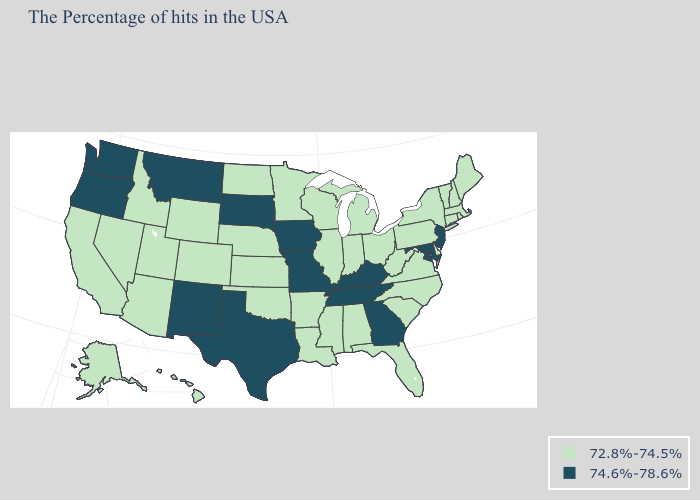What is the value of Georgia?
Be succinct. 74.6%-78.6%. Does New Hampshire have the lowest value in the Northeast?
Give a very brief answer. Yes. Does Maine have the same value as South Dakota?
Concise answer only. No. Name the states that have a value in the range 72.8%-74.5%?
Give a very brief answer. Maine, Massachusetts, Rhode Island, New Hampshire, Vermont, Connecticut, New York, Delaware, Pennsylvania, Virginia, North Carolina, South Carolina, West Virginia, Ohio, Florida, Michigan, Indiana, Alabama, Wisconsin, Illinois, Mississippi, Louisiana, Arkansas, Minnesota, Kansas, Nebraska, Oklahoma, North Dakota, Wyoming, Colorado, Utah, Arizona, Idaho, Nevada, California, Alaska, Hawaii. Does Missouri have a higher value than Kentucky?
Short answer required. No. Which states have the lowest value in the USA?
Be succinct. Maine, Massachusetts, Rhode Island, New Hampshire, Vermont, Connecticut, New York, Delaware, Pennsylvania, Virginia, North Carolina, South Carolina, West Virginia, Ohio, Florida, Michigan, Indiana, Alabama, Wisconsin, Illinois, Mississippi, Louisiana, Arkansas, Minnesota, Kansas, Nebraska, Oklahoma, North Dakota, Wyoming, Colorado, Utah, Arizona, Idaho, Nevada, California, Alaska, Hawaii. Does Wyoming have the same value as Vermont?
Concise answer only. Yes. What is the lowest value in states that border Idaho?
Write a very short answer. 72.8%-74.5%. What is the value of Illinois?
Keep it brief. 72.8%-74.5%. Name the states that have a value in the range 74.6%-78.6%?
Answer briefly. New Jersey, Maryland, Georgia, Kentucky, Tennessee, Missouri, Iowa, Texas, South Dakota, New Mexico, Montana, Washington, Oregon. What is the value of West Virginia?
Concise answer only. 72.8%-74.5%. What is the highest value in the USA?
Be succinct. 74.6%-78.6%. Name the states that have a value in the range 72.8%-74.5%?
Keep it brief. Maine, Massachusetts, Rhode Island, New Hampshire, Vermont, Connecticut, New York, Delaware, Pennsylvania, Virginia, North Carolina, South Carolina, West Virginia, Ohio, Florida, Michigan, Indiana, Alabama, Wisconsin, Illinois, Mississippi, Louisiana, Arkansas, Minnesota, Kansas, Nebraska, Oklahoma, North Dakota, Wyoming, Colorado, Utah, Arizona, Idaho, Nevada, California, Alaska, Hawaii. What is the value of West Virginia?
Give a very brief answer. 72.8%-74.5%. 